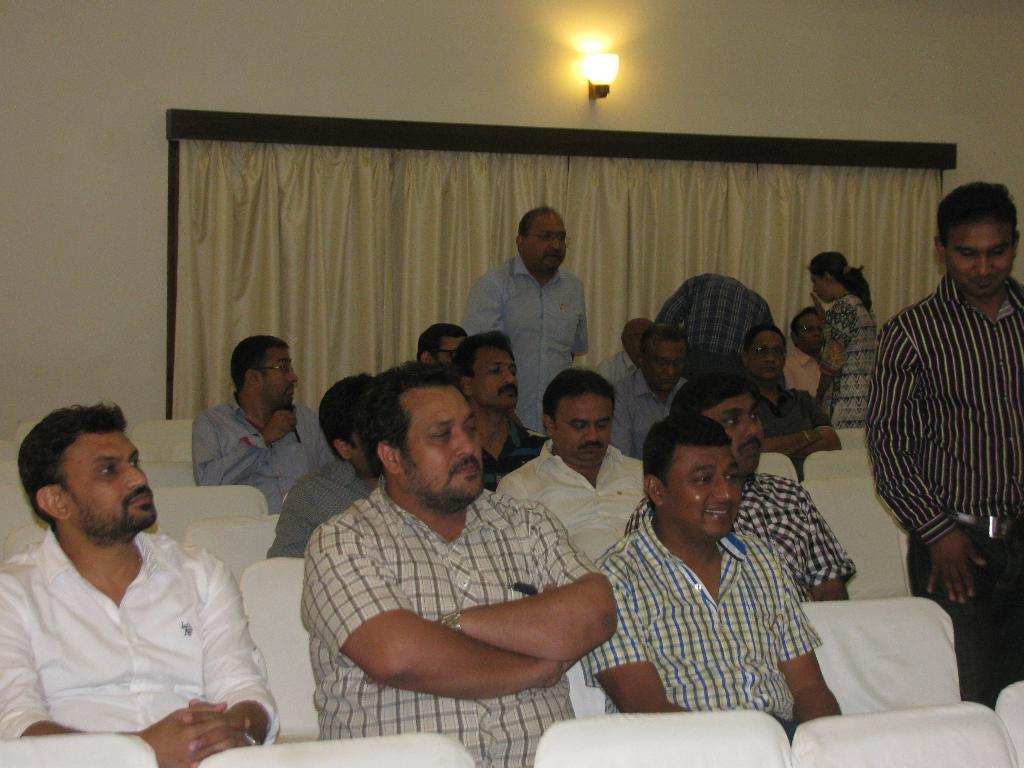What are the people in the image doing? There is a group of people sitting on chairs in the image. What is the position of the man in the image? A man is standing in the middle of the image. Can you describe the lighting in the image? There is a light at the top on the wall in the image. What is behind the man in the image? There is a curtain behind the man in the image. What type of mountain can be seen in the background of the image? There is no mountain visible in the image; it features a group of people sitting on chairs, a man standing in the middle, a light at the top on the wall, and a curtain behind the man. 